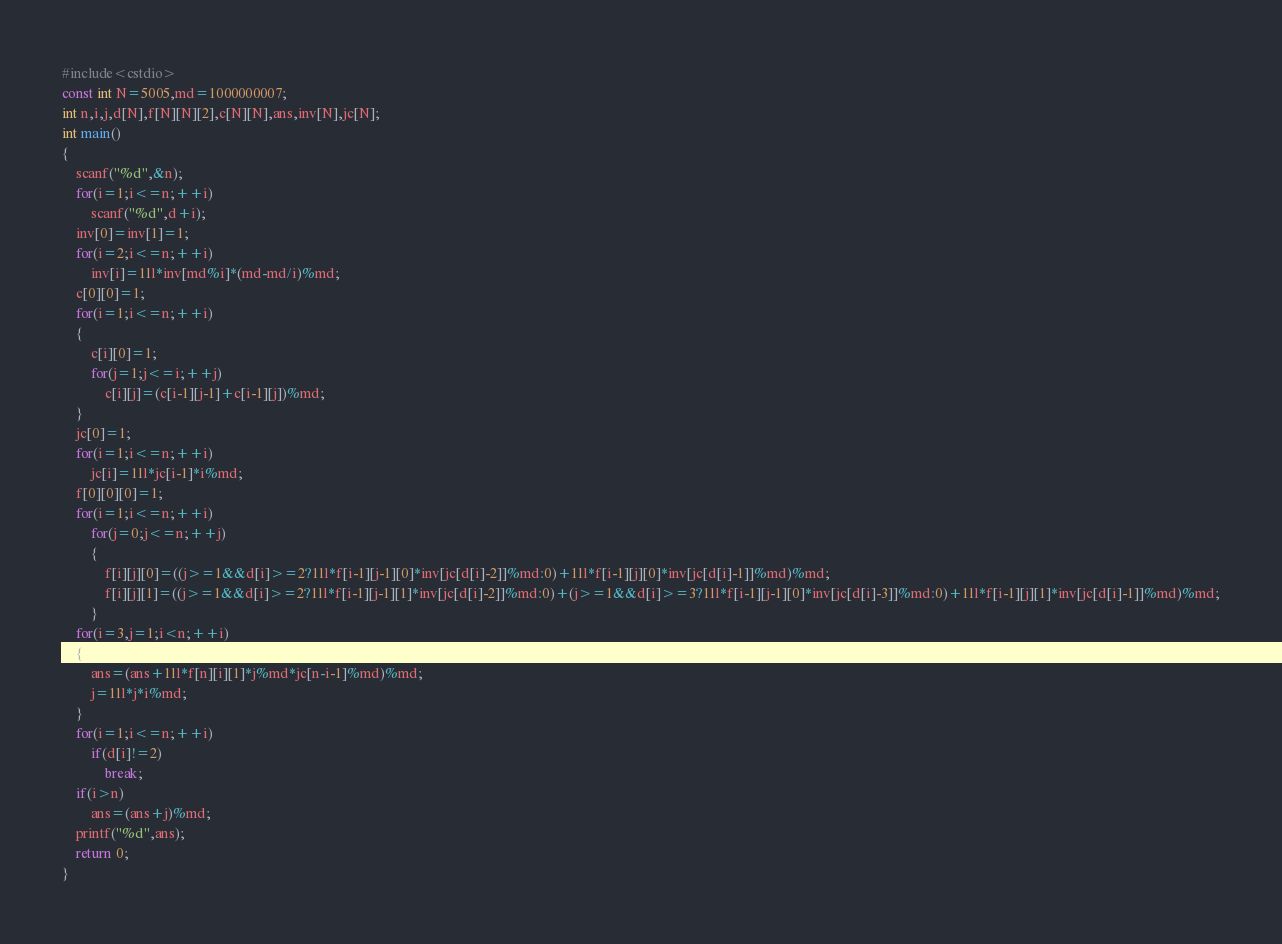<code> <loc_0><loc_0><loc_500><loc_500><_C++_>#include<cstdio>
const int N=5005,md=1000000007;
int n,i,j,d[N],f[N][N][2],c[N][N],ans,inv[N],jc[N];
int main()
{
	scanf("%d",&n);
	for(i=1;i<=n;++i)
		scanf("%d",d+i);
	inv[0]=inv[1]=1;
	for(i=2;i<=n;++i)
		inv[i]=1ll*inv[md%i]*(md-md/i)%md;
	c[0][0]=1;
	for(i=1;i<=n;++i)
	{
		c[i][0]=1;
		for(j=1;j<=i;++j)
			c[i][j]=(c[i-1][j-1]+c[i-1][j])%md;
	}
	jc[0]=1;
	for(i=1;i<=n;++i)
		jc[i]=1ll*jc[i-1]*i%md;
	f[0][0][0]=1;
	for(i=1;i<=n;++i)
		for(j=0;j<=n;++j)
		{
			f[i][j][0]=((j>=1&&d[i]>=2?1ll*f[i-1][j-1][0]*inv[jc[d[i]-2]]%md:0)+1ll*f[i-1][j][0]*inv[jc[d[i]-1]]%md)%md;
			f[i][j][1]=((j>=1&&d[i]>=2?1ll*f[i-1][j-1][1]*inv[jc[d[i]-2]]%md:0)+(j>=1&&d[i]>=3?1ll*f[i-1][j-1][0]*inv[jc[d[i]-3]]%md:0)+1ll*f[i-1][j][1]*inv[jc[d[i]-1]]%md)%md;
		}
	for(i=3,j=1;i<n;++i)
	{
		ans=(ans+1ll*f[n][i][1]*j%md*jc[n-i-1]%md)%md;
		j=1ll*j*i%md;
	}
	for(i=1;i<=n;++i)
		if(d[i]!=2)
			break;
	if(i>n)
		ans=(ans+j)%md;
	printf("%d",ans);
	return 0;
}
</code> 